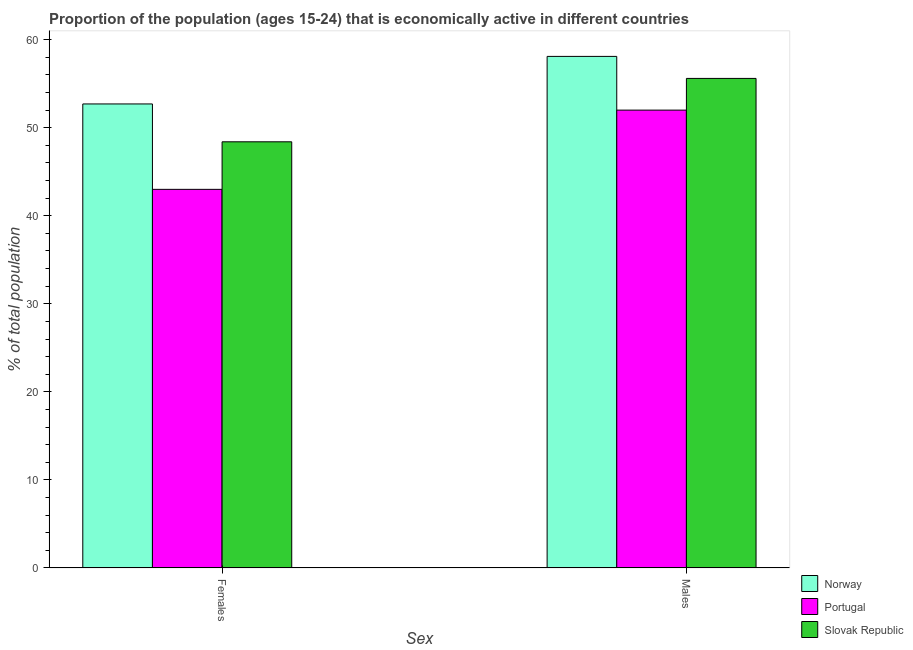How many different coloured bars are there?
Provide a short and direct response. 3. How many groups of bars are there?
Your answer should be very brief. 2. How many bars are there on the 2nd tick from the left?
Offer a very short reply. 3. What is the label of the 1st group of bars from the left?
Ensure brevity in your answer.  Females. What is the percentage of economically active male population in Slovak Republic?
Offer a terse response. 55.6. Across all countries, what is the maximum percentage of economically active female population?
Your answer should be very brief. 52.7. Across all countries, what is the minimum percentage of economically active female population?
Offer a terse response. 43. In which country was the percentage of economically active male population maximum?
Provide a short and direct response. Norway. In which country was the percentage of economically active female population minimum?
Ensure brevity in your answer.  Portugal. What is the total percentage of economically active female population in the graph?
Provide a succinct answer. 144.1. What is the difference between the percentage of economically active female population in Norway and that in Portugal?
Ensure brevity in your answer.  9.7. What is the difference between the percentage of economically active female population in Portugal and the percentage of economically active male population in Slovak Republic?
Offer a very short reply. -12.6. What is the average percentage of economically active male population per country?
Offer a very short reply. 55.23. What is the difference between the percentage of economically active female population and percentage of economically active male population in Norway?
Your answer should be compact. -5.4. In how many countries, is the percentage of economically active male population greater than 52 %?
Provide a short and direct response. 2. What is the ratio of the percentage of economically active female population in Norway to that in Portugal?
Keep it short and to the point. 1.23. Is the percentage of economically active female population in Portugal less than that in Norway?
Your answer should be compact. Yes. In how many countries, is the percentage of economically active female population greater than the average percentage of economically active female population taken over all countries?
Offer a very short reply. 2. What does the 1st bar from the left in Females represents?
Ensure brevity in your answer.  Norway. What does the 1st bar from the right in Males represents?
Offer a terse response. Slovak Republic. How many bars are there?
Ensure brevity in your answer.  6. How many countries are there in the graph?
Give a very brief answer. 3. What is the difference between two consecutive major ticks on the Y-axis?
Make the answer very short. 10. Are the values on the major ticks of Y-axis written in scientific E-notation?
Your answer should be compact. No. Where does the legend appear in the graph?
Your answer should be very brief. Bottom right. What is the title of the graph?
Give a very brief answer. Proportion of the population (ages 15-24) that is economically active in different countries. Does "Madagascar" appear as one of the legend labels in the graph?
Provide a succinct answer. No. What is the label or title of the X-axis?
Keep it short and to the point. Sex. What is the label or title of the Y-axis?
Offer a terse response. % of total population. What is the % of total population in Norway in Females?
Offer a very short reply. 52.7. What is the % of total population in Slovak Republic in Females?
Offer a very short reply. 48.4. What is the % of total population of Norway in Males?
Your response must be concise. 58.1. What is the % of total population of Portugal in Males?
Provide a succinct answer. 52. What is the % of total population of Slovak Republic in Males?
Your answer should be very brief. 55.6. Across all Sex, what is the maximum % of total population of Norway?
Give a very brief answer. 58.1. Across all Sex, what is the maximum % of total population of Portugal?
Your response must be concise. 52. Across all Sex, what is the maximum % of total population in Slovak Republic?
Provide a succinct answer. 55.6. Across all Sex, what is the minimum % of total population in Norway?
Ensure brevity in your answer.  52.7. Across all Sex, what is the minimum % of total population in Slovak Republic?
Give a very brief answer. 48.4. What is the total % of total population of Norway in the graph?
Your answer should be compact. 110.8. What is the total % of total population in Portugal in the graph?
Ensure brevity in your answer.  95. What is the total % of total population in Slovak Republic in the graph?
Your response must be concise. 104. What is the difference between the % of total population in Portugal in Females and that in Males?
Your answer should be compact. -9. What is the difference between the % of total population in Slovak Republic in Females and that in Males?
Your response must be concise. -7.2. What is the average % of total population in Norway per Sex?
Ensure brevity in your answer.  55.4. What is the average % of total population of Portugal per Sex?
Keep it short and to the point. 47.5. What is the difference between the % of total population in Portugal and % of total population in Slovak Republic in Females?
Make the answer very short. -5.4. What is the difference between the % of total population of Norway and % of total population of Portugal in Males?
Your answer should be compact. 6.1. What is the difference between the % of total population in Norway and % of total population in Slovak Republic in Males?
Your answer should be very brief. 2.5. What is the difference between the % of total population of Portugal and % of total population of Slovak Republic in Males?
Give a very brief answer. -3.6. What is the ratio of the % of total population in Norway in Females to that in Males?
Provide a succinct answer. 0.91. What is the ratio of the % of total population in Portugal in Females to that in Males?
Provide a short and direct response. 0.83. What is the ratio of the % of total population of Slovak Republic in Females to that in Males?
Offer a very short reply. 0.87. What is the difference between the highest and the lowest % of total population in Norway?
Provide a succinct answer. 5.4. What is the difference between the highest and the lowest % of total population in Portugal?
Your response must be concise. 9. What is the difference between the highest and the lowest % of total population in Slovak Republic?
Provide a short and direct response. 7.2. 